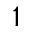Convert formula to latex. <formula><loc_0><loc_0><loc_500><loc_500>^ { 1 }</formula> 